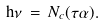<formula> <loc_0><loc_0><loc_500><loc_500>\mathrm h \nu \, = \, N _ { c } ( \tau \alpha ) .</formula> 